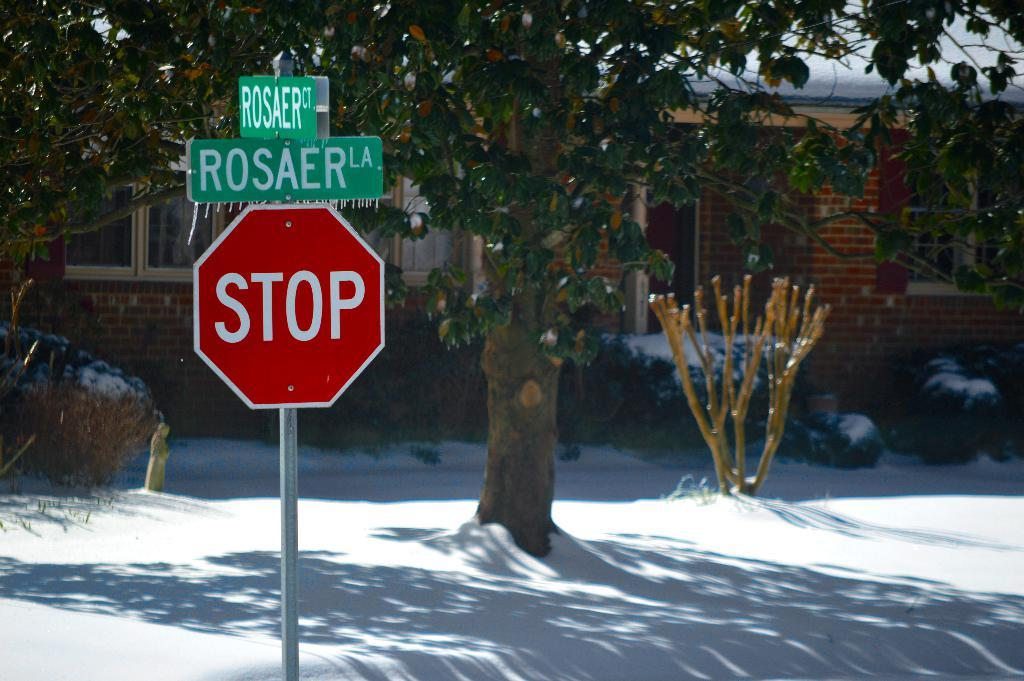<image>
Share a concise interpretation of the image provided. A stop sign is  on Rosaer street in front of a house. 